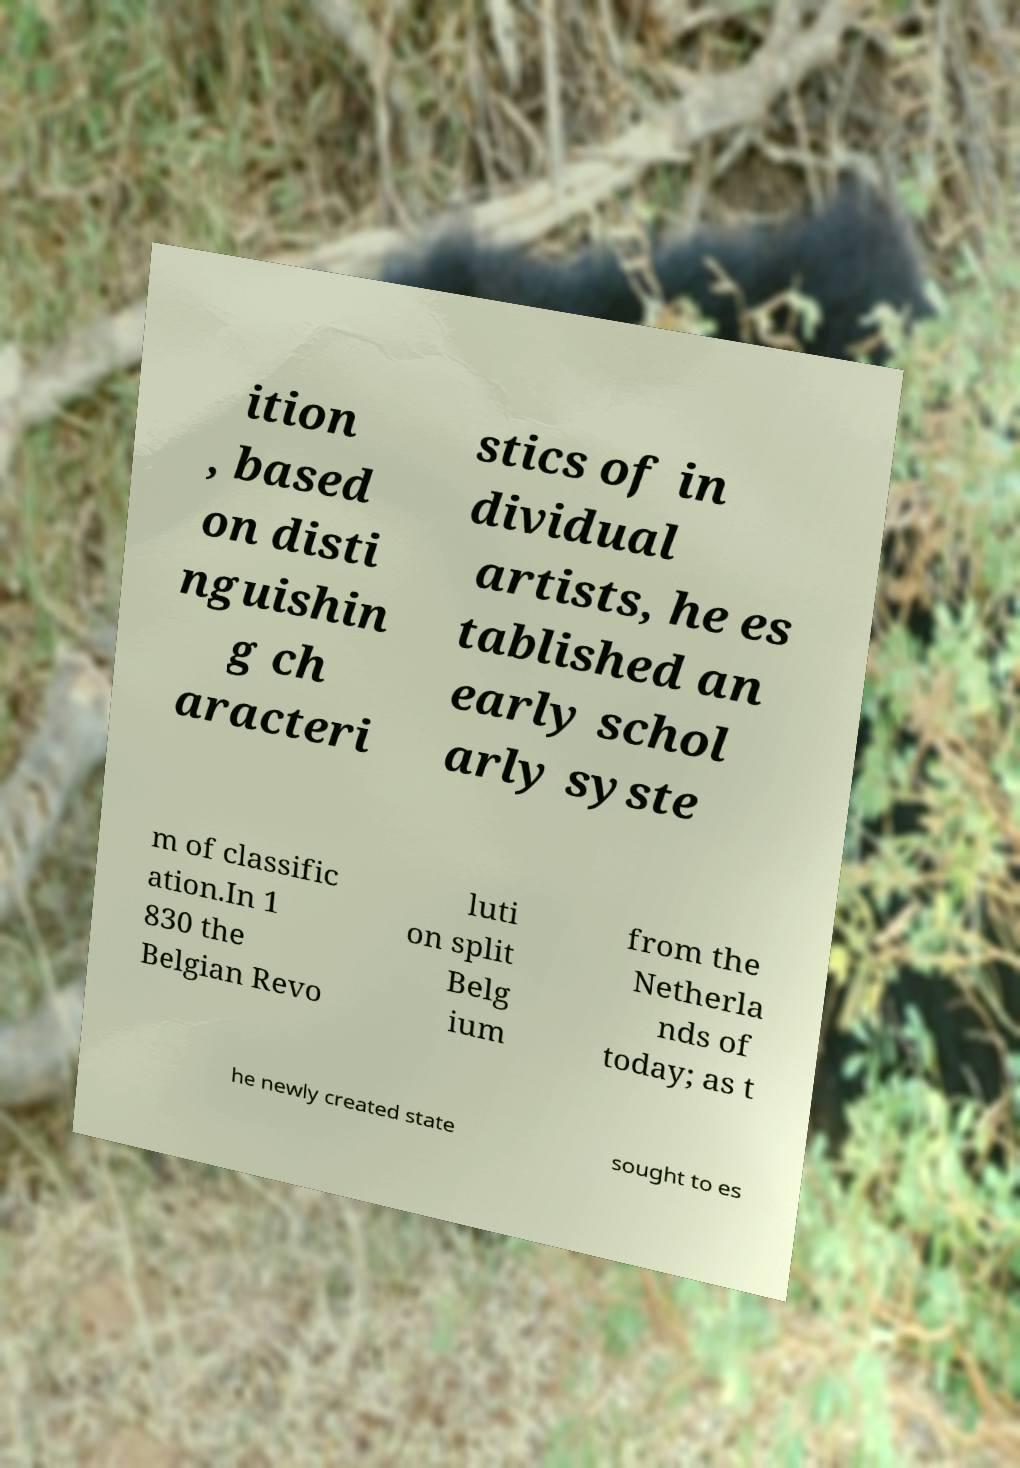There's text embedded in this image that I need extracted. Can you transcribe it verbatim? ition , based on disti nguishin g ch aracteri stics of in dividual artists, he es tablished an early schol arly syste m of classific ation.In 1 830 the Belgian Revo luti on split Belg ium from the Netherla nds of today; as t he newly created state sought to es 